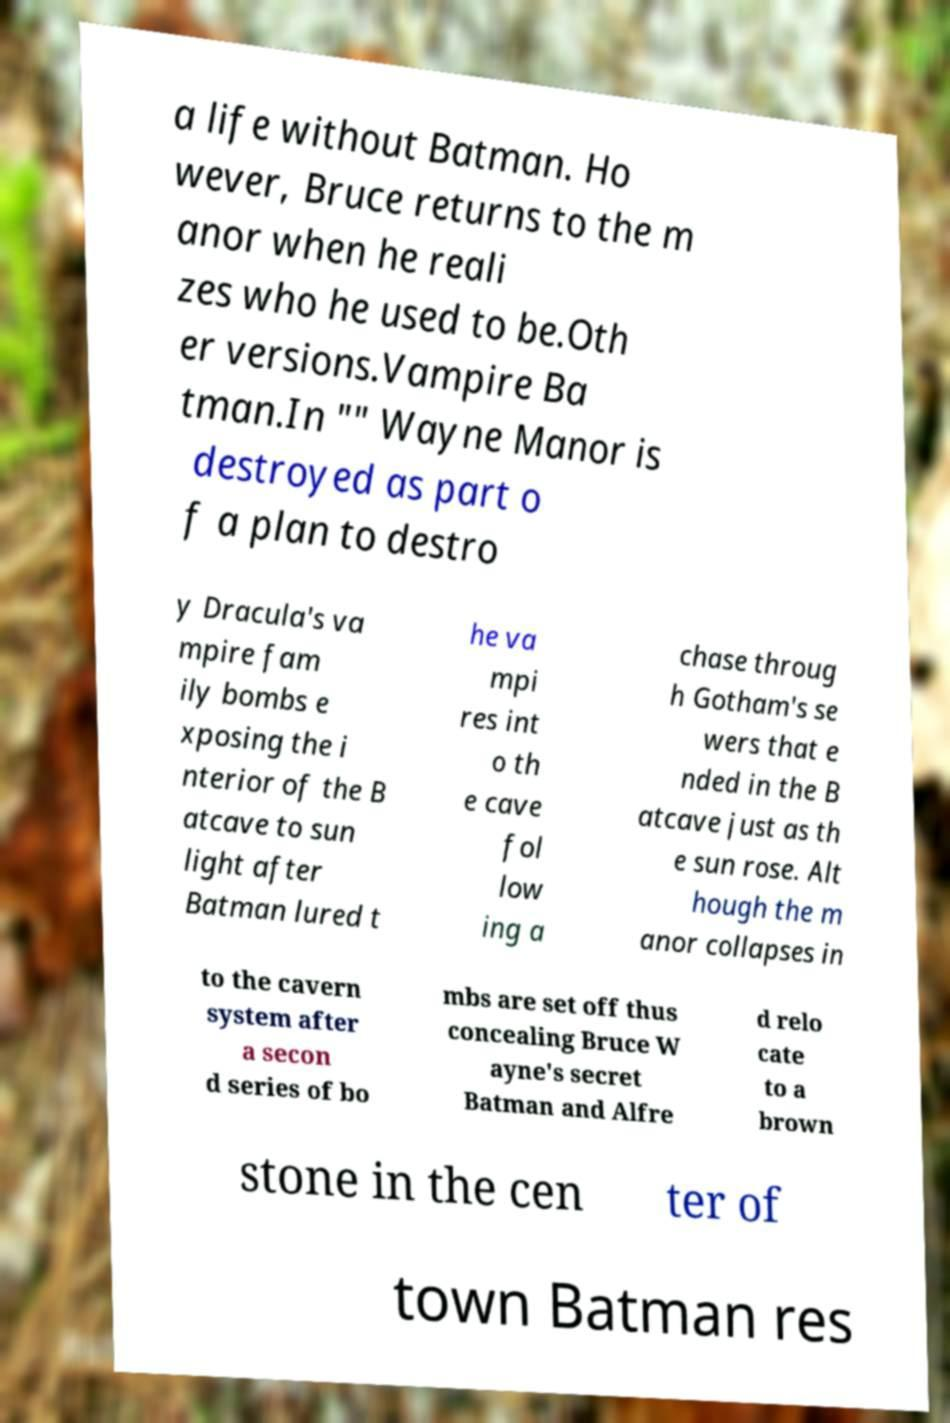What messages or text are displayed in this image? I need them in a readable, typed format. a life without Batman. Ho wever, Bruce returns to the m anor when he reali zes who he used to be.Oth er versions.Vampire Ba tman.In "" Wayne Manor is destroyed as part o f a plan to destro y Dracula's va mpire fam ily bombs e xposing the i nterior of the B atcave to sun light after Batman lured t he va mpi res int o th e cave fol low ing a chase throug h Gotham's se wers that e nded in the B atcave just as th e sun rose. Alt hough the m anor collapses in to the cavern system after a secon d series of bo mbs are set off thus concealing Bruce W ayne's secret Batman and Alfre d relo cate to a brown stone in the cen ter of town Batman res 